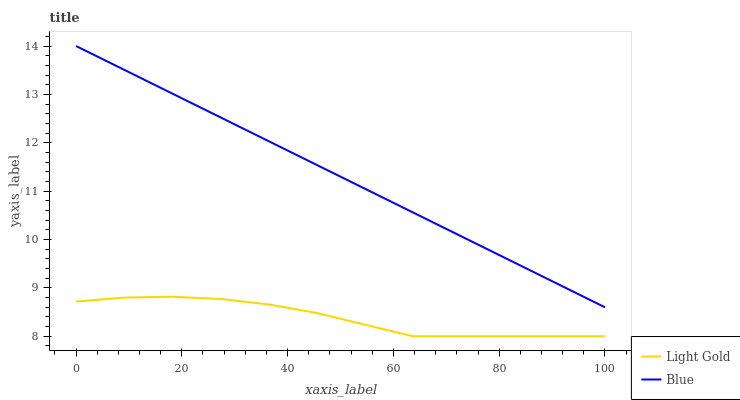Does Light Gold have the maximum area under the curve?
Answer yes or no. No. Is Light Gold the smoothest?
Answer yes or no. No. Does Light Gold have the highest value?
Answer yes or no. No. Is Light Gold less than Blue?
Answer yes or no. Yes. Is Blue greater than Light Gold?
Answer yes or no. Yes. Does Light Gold intersect Blue?
Answer yes or no. No. 